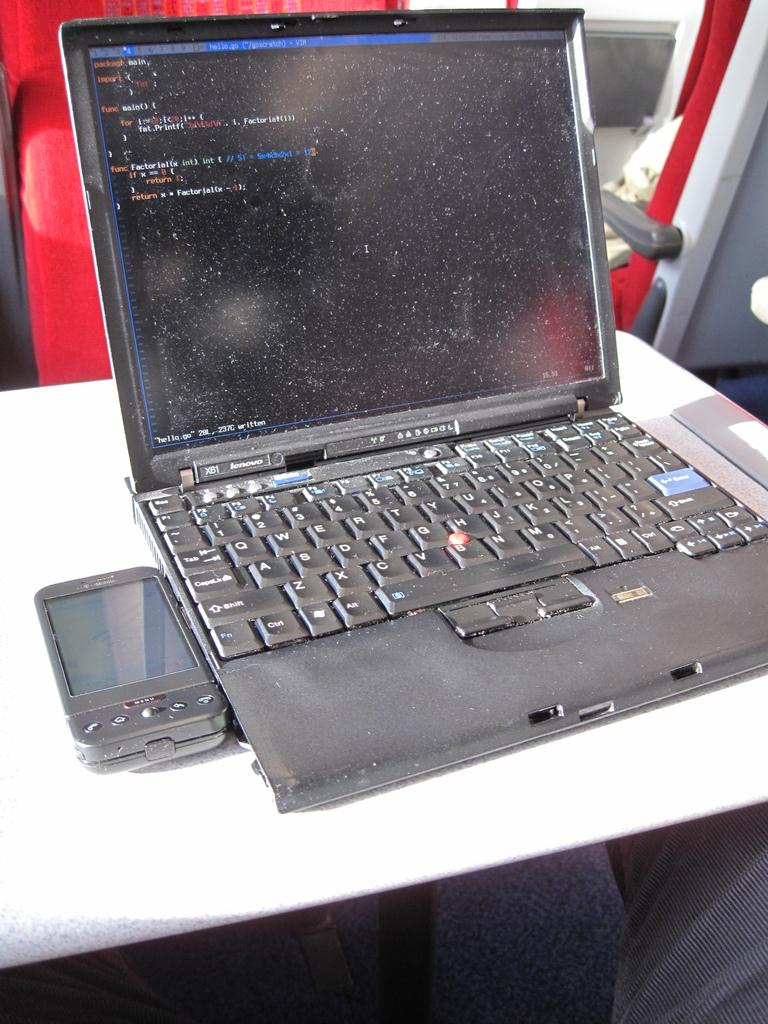<image>
Create a compact narrative representing the image presented. A Lenova computer with a dusty screen next to a phone 